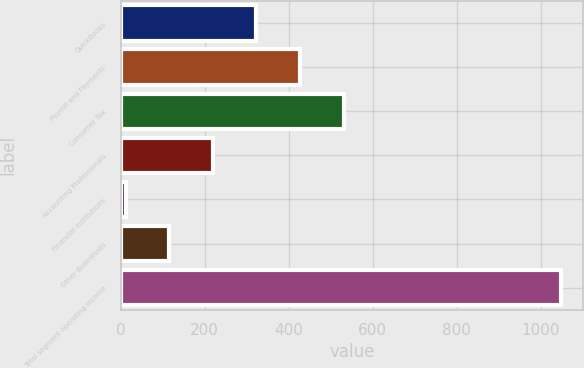Convert chart to OTSL. <chart><loc_0><loc_0><loc_500><loc_500><bar_chart><fcel>QuickBooks<fcel>Payroll and Payments<fcel>Consumer Tax<fcel>Accounting Professionals<fcel>Financial Institutions<fcel>Other Businesses<fcel>Total segment operating income<nl><fcel>323.27<fcel>426.96<fcel>530.65<fcel>219.58<fcel>12.2<fcel>115.89<fcel>1049.1<nl></chart> 